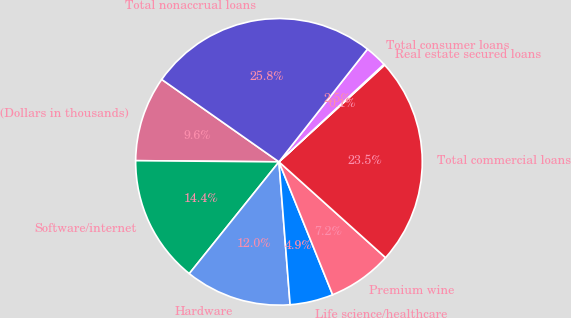Convert chart to OTSL. <chart><loc_0><loc_0><loc_500><loc_500><pie_chart><fcel>(Dollars in thousands)<fcel>Software/internet<fcel>Hardware<fcel>Life science/healthcare<fcel>Premium wine<fcel>Total commercial loans<fcel>Real estate secured loans<fcel>Total consumer loans<fcel>Total nonaccrual loans<nl><fcel>9.62%<fcel>14.37%<fcel>12.0%<fcel>4.87%<fcel>7.24%<fcel>23.46%<fcel>0.11%<fcel>2.49%<fcel>25.84%<nl></chart> 